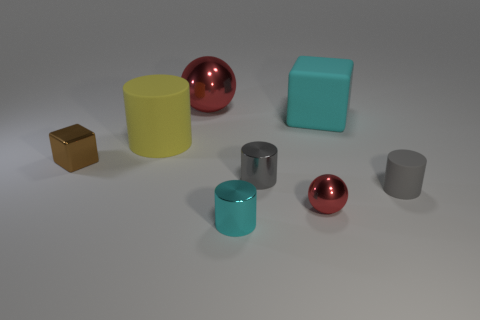Add 1 cyan matte things. How many objects exist? 9 Subtract all spheres. How many objects are left? 6 Add 2 tiny metal things. How many tiny metal things exist? 6 Subtract 0 purple balls. How many objects are left? 8 Subtract all small gray cylinders. Subtract all spheres. How many objects are left? 4 Add 5 large matte blocks. How many large matte blocks are left? 6 